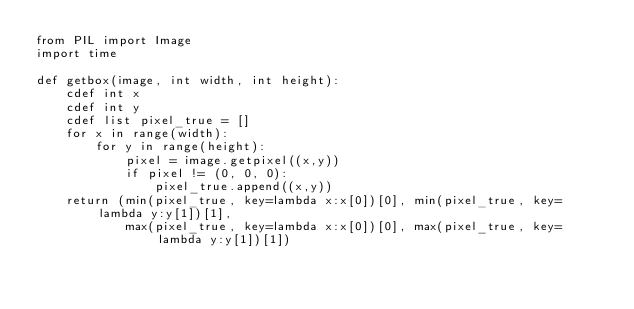<code> <loc_0><loc_0><loc_500><loc_500><_Cython_>from PIL import Image
import time

def getbox(image, int width, int height): 
    cdef int x
    cdef int y 
    cdef list pixel_true = []
    for x in range(width):
        for y in range(height):
            pixel = image.getpixel((x,y))
            if pixel != (0, 0, 0):
                pixel_true.append((x,y))
    return (min(pixel_true, key=lambda x:x[0])[0], min(pixel_true, key= lambda y:y[1])[1], 
            max(pixel_true, key=lambda x:x[0])[0], max(pixel_true, key= lambda y:y[1])[1])
</code> 